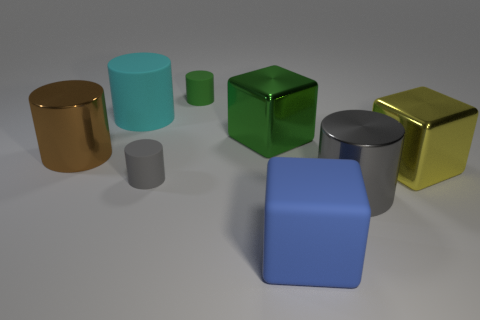Is there anything else that is made of the same material as the cyan cylinder?
Your answer should be compact. Yes. Do the brown shiny cylinder and the yellow object have the same size?
Offer a terse response. Yes. There is a large brown cylinder; are there any large blue blocks behind it?
Provide a short and direct response. No. How big is the rubber thing that is both behind the gray metallic cylinder and in front of the big cyan cylinder?
Offer a terse response. Small. What number of things are yellow cylinders or large yellow metallic cubes?
Keep it short and to the point. 1. There is a rubber block; is its size the same as the metal block on the right side of the big gray metallic object?
Your response must be concise. Yes. There is a metal cylinder to the right of the tiny gray matte cylinder that is in front of the metallic block left of the big blue cube; how big is it?
Ensure brevity in your answer.  Large. Are there any large green rubber blocks?
Provide a succinct answer. No. What number of things are large shiny cylinders left of the big gray metallic thing or metallic things that are right of the large matte cylinder?
Provide a succinct answer. 4. There is a tiny rubber thing behind the brown cylinder; what number of small objects are in front of it?
Give a very brief answer. 1. 